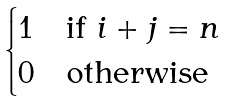<formula> <loc_0><loc_0><loc_500><loc_500>\begin{cases} 1 & \text {if $i+j=n$} \\ 0 & \text {otherwise} \end{cases}</formula> 